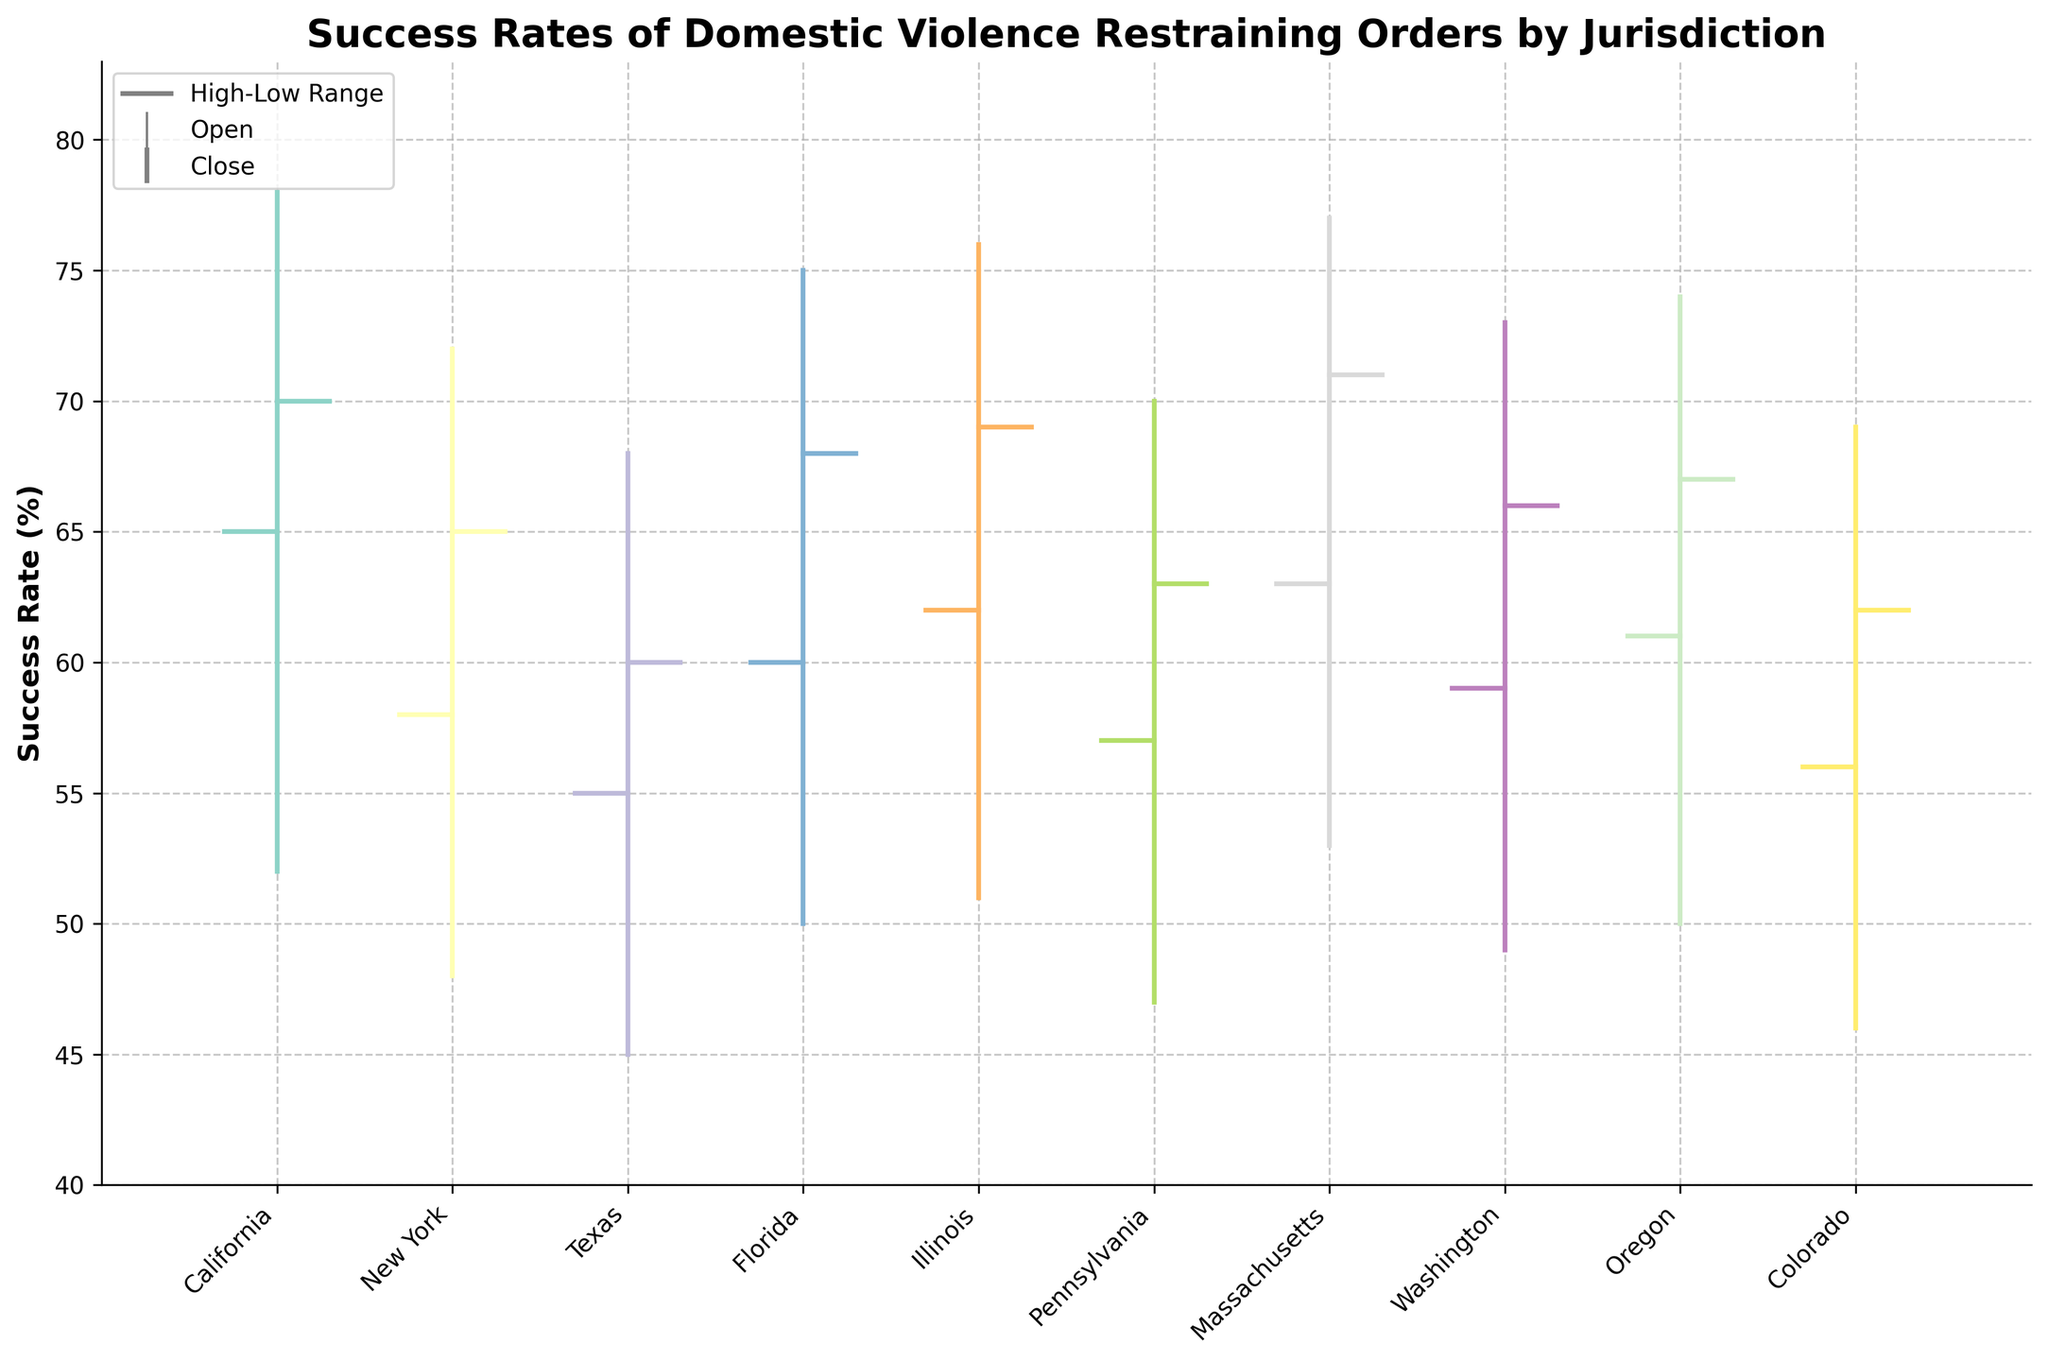What's the title of the figure? The title is located at the top of the figure and it summarizes what the plot is about. It states: "Success Rates of Domestic Violence Restraining Orders by Jurisdiction".
Answer: Success Rates of Domestic Violence Restraining Orders by Jurisdiction What does the y-axis represent? The y-axis is labeled as "Success Rate (%)", which indicates that it represents the percentage success rates of the domestic violence restraining orders.
Answer: Success Rate (%) Which jurisdiction has the highest success rate for domestic violence restraining orders? By looking at the high values for each jurisdiction, Massachusetts has the highest value at 77%.
Answer: Massachusetts What is the range of success rates for New York? The range can be found by subtracting the low value from the high value for New York. High is 72% and Low is 48%, so the range is 72% - 48% = 24%.
Answer: 24% Between California and Texas, which one has a higher closing success rate? The closing rate is represented by the horizontal line extending to the right. California has a close of 70%, whereas Texas has a close of 60%. Therefore, California has a higher closing success rate.
Answer: California On average, is the opening success rate higher or lower for the jurisdictions compared to their closing success rates? To determine this, we'll compare the average opening rate to the average closing rate. Average of opens: (65+58+55+60+62+57+63+59+61+56)/10 = 59.6%. Average of closes: (70+65+60+68+69+63+71+66+67+62)/10 = 66.1%. The closing rates are generally higher.
Answer: Higher What is the difference between the high and low success rates for Illinois? The high rate for Illinois is 76% and the low rate is 51%, so the difference is 76% - 51% = 25%.
Answer: 25% How many jurisdictions have a closing success rate above 65%? By examining the closing rates, California (70%), Florida (68%), Illinois (69%), Oregon (67%), and Massachusetts (71%) exceed 65%. Hence, 5 jurisdictions.
Answer: 5 Which jurisdiction has the smallest range of success rates (difference between high and low)? By calculating the range for each jurisdiction and comparing them, New York has the smallest range: 72% - 48% = 24%
Answer: New York Is there any jurisdiction where the low success rate is lower than 50%? By checking the low success rate values, New York (48%), Texas (45%), Florida (50%), Pennsylvania (47%), and Colorado (46%) have low values, but only New York, Texas, and Pennsylvania are below 50%.
Answer: Yes (New York, Texas, Pennsylvania) 